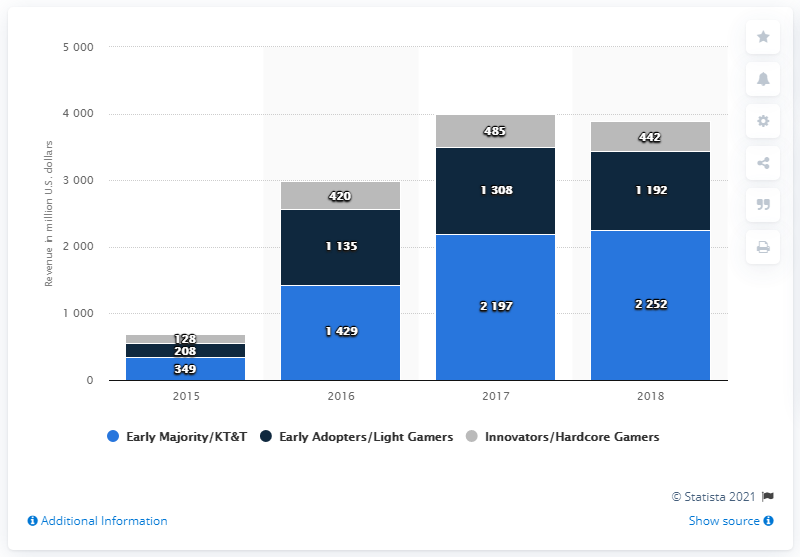Identify some key points in this picture. In 2017, there were 823 more early adopters than innovators. Early adopters reached their peak usage in the year 2017. 